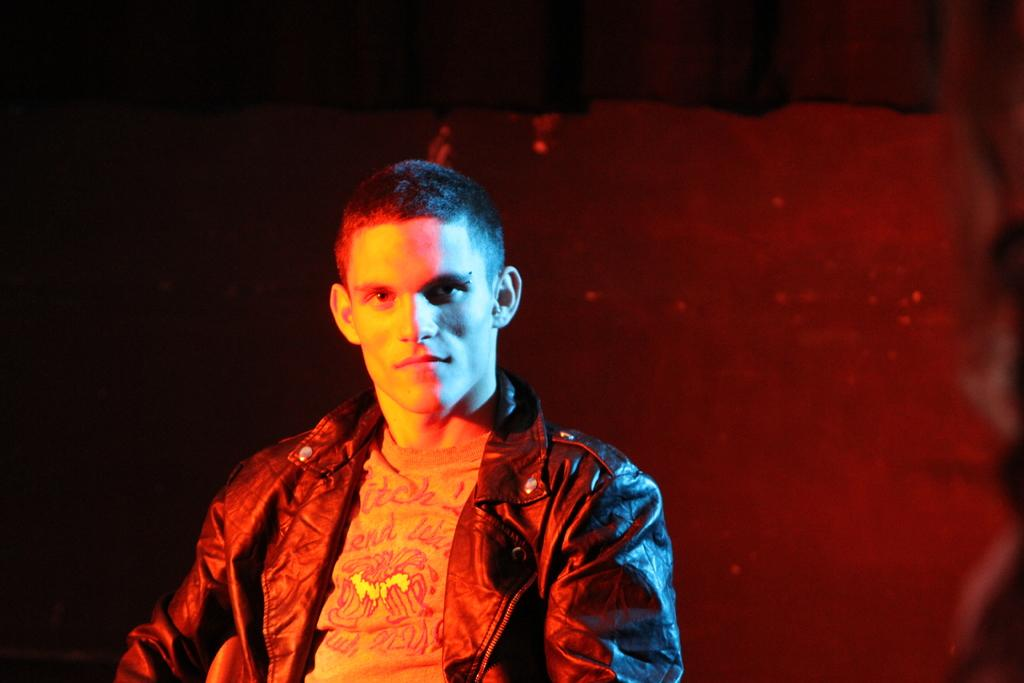Who or what is the main subject in the image? There is a person in the image. Can you describe the background of the image? The background of the image is dark and blurred. What type of glue is being used by the person in the image? There is no glue present in the image, and the person's actions are not described. 